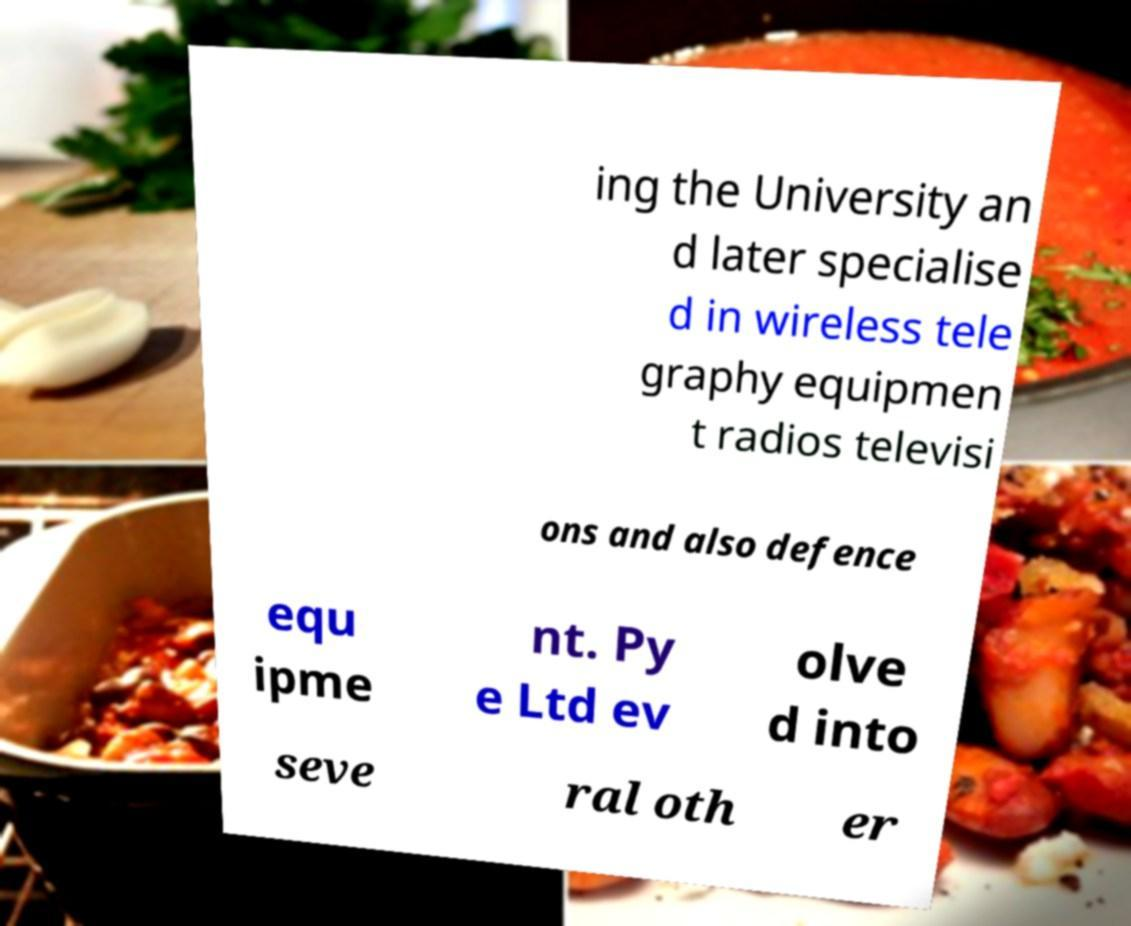For documentation purposes, I need the text within this image transcribed. Could you provide that? ing the University an d later specialise d in wireless tele graphy equipmen t radios televisi ons and also defence equ ipme nt. Py e Ltd ev olve d into seve ral oth er 